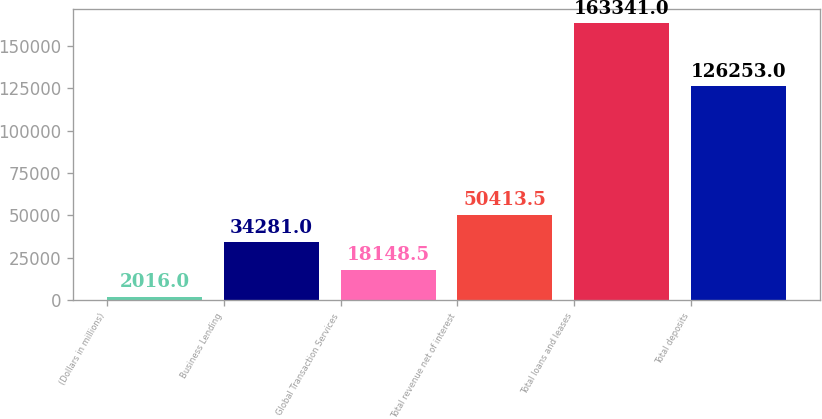Convert chart. <chart><loc_0><loc_0><loc_500><loc_500><bar_chart><fcel>(Dollars in millions)<fcel>Business Lending<fcel>Global Transaction Services<fcel>Total revenue net of interest<fcel>Total loans and leases<fcel>Total deposits<nl><fcel>2016<fcel>34281<fcel>18148.5<fcel>50413.5<fcel>163341<fcel>126253<nl></chart> 